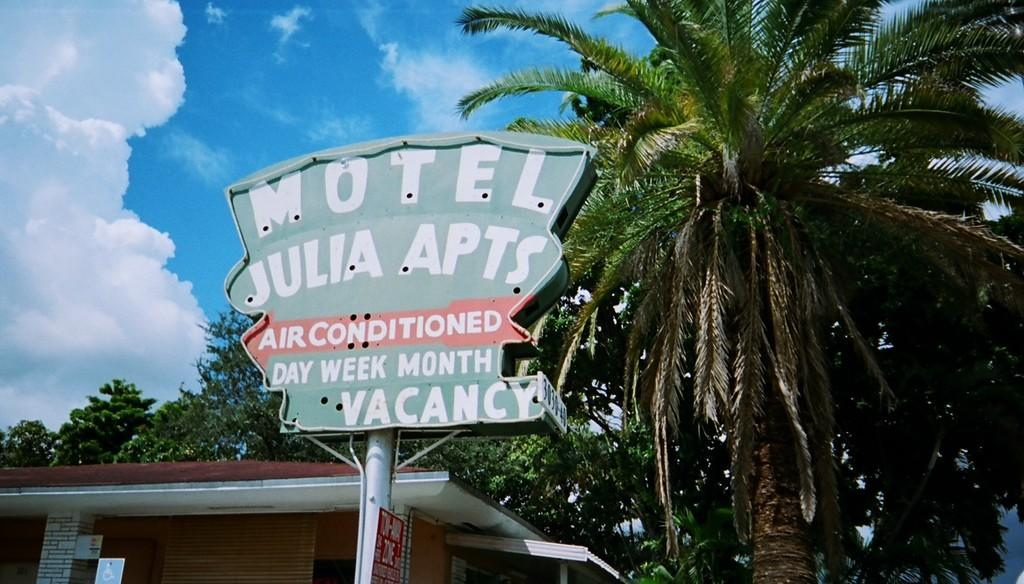What type of vegetation is on the right side of the image? There are trees on the right side of the image. What structure is located at the bottom of the image? There is a house at the bottom of the image. What is in the middle of the image? There is a board, a pole, and a poster in the middle of the image. What is written on the board? There is text on the board. What can be seen in the background of the image? There are trees, sky, and clouds visible in the background of the image. How does the orange balance on the pole in the image? There is no orange present in the image; it only features a board, a pole, and a poster. What type of door is visible in the image? There is no door present in the image. 